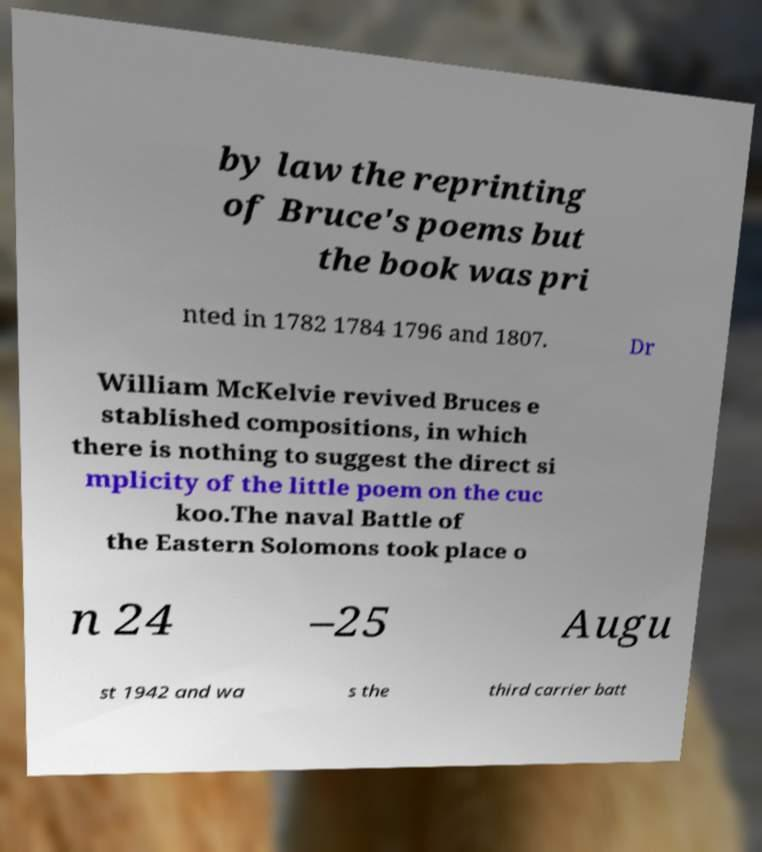Can you accurately transcribe the text from the provided image for me? by law the reprinting of Bruce's poems but the book was pri nted in 1782 1784 1796 and 1807. Dr William McKelvie revived Bruces e stablished compositions, in which there is nothing to suggest the direct si mplicity of the little poem on the cuc koo.The naval Battle of the Eastern Solomons took place o n 24 –25 Augu st 1942 and wa s the third carrier batt 